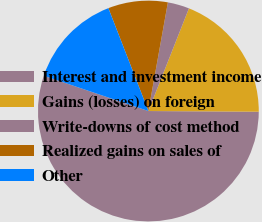<chart> <loc_0><loc_0><loc_500><loc_500><pie_chart><fcel>Interest and investment income<fcel>Gains (losses) on foreign<fcel>Write-downs of cost method<fcel>Realized gains on sales of<fcel>Other<nl><fcel>55.08%<fcel>19.11%<fcel>3.16%<fcel>8.73%<fcel>13.92%<nl></chart> 